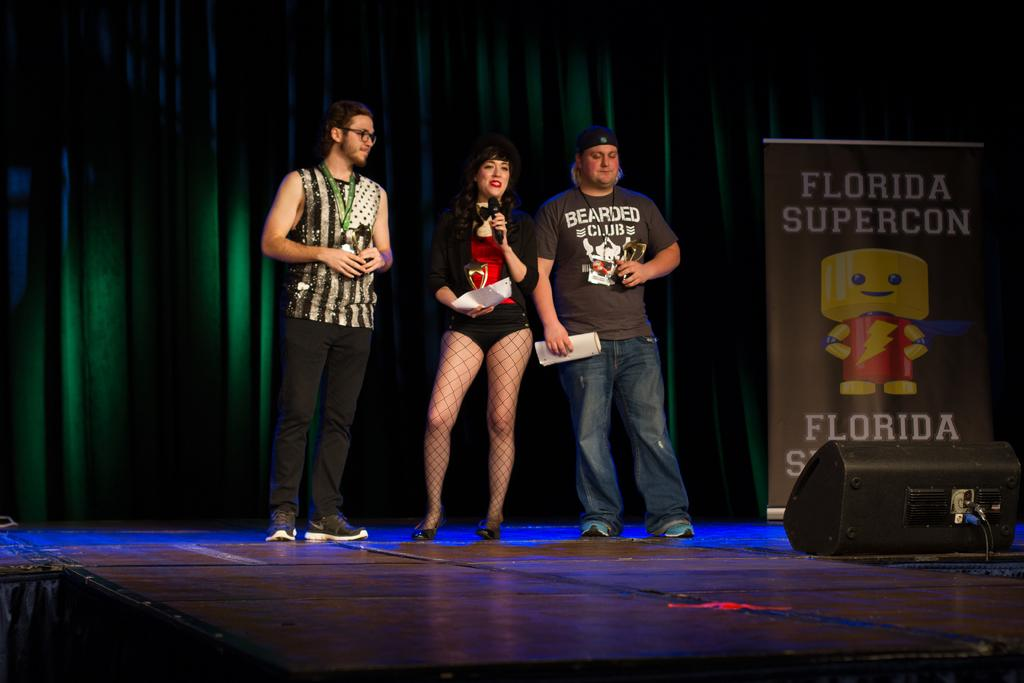<image>
Summarize the visual content of the image. three people are standing on a stage with a large florida supercon sign next to them. 